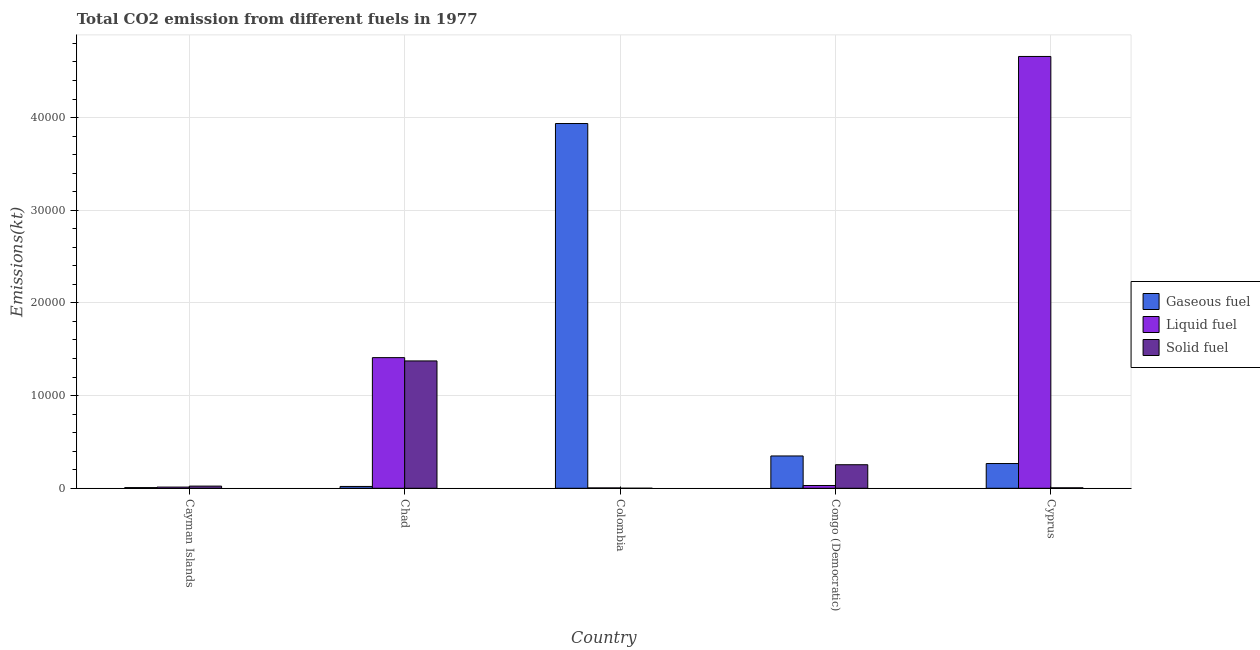How many groups of bars are there?
Provide a succinct answer. 5. Are the number of bars on each tick of the X-axis equal?
Keep it short and to the point. Yes. How many bars are there on the 2nd tick from the right?
Offer a terse response. 3. What is the label of the 4th group of bars from the left?
Your answer should be very brief. Congo (Democratic). In how many cases, is the number of bars for a given country not equal to the number of legend labels?
Give a very brief answer. 0. What is the amount of co2 emissions from solid fuel in Chad?
Provide a short and direct response. 1.37e+04. Across all countries, what is the maximum amount of co2 emissions from gaseous fuel?
Ensure brevity in your answer.  3.94e+04. Across all countries, what is the minimum amount of co2 emissions from solid fuel?
Your response must be concise. 3.67. In which country was the amount of co2 emissions from liquid fuel maximum?
Give a very brief answer. Cyprus. What is the total amount of co2 emissions from liquid fuel in the graph?
Offer a terse response. 6.12e+04. What is the difference between the amount of co2 emissions from liquid fuel in Chad and that in Colombia?
Make the answer very short. 1.41e+04. What is the difference between the amount of co2 emissions from solid fuel in Cyprus and the amount of co2 emissions from gaseous fuel in Colombia?
Provide a short and direct response. -3.93e+04. What is the average amount of co2 emissions from solid fuel per country?
Give a very brief answer. 3314.23. What is the difference between the amount of co2 emissions from solid fuel and amount of co2 emissions from gaseous fuel in Cayman Islands?
Provide a short and direct response. 161.35. In how many countries, is the amount of co2 emissions from gaseous fuel greater than 18000 kt?
Provide a succinct answer. 1. What is the ratio of the amount of co2 emissions from gaseous fuel in Chad to that in Congo (Democratic)?
Keep it short and to the point. 0.06. Is the amount of co2 emissions from solid fuel in Chad less than that in Congo (Democratic)?
Provide a short and direct response. No. What is the difference between the highest and the second highest amount of co2 emissions from solid fuel?
Provide a short and direct response. 1.12e+04. What is the difference between the highest and the lowest amount of co2 emissions from gaseous fuel?
Give a very brief answer. 3.93e+04. In how many countries, is the amount of co2 emissions from gaseous fuel greater than the average amount of co2 emissions from gaseous fuel taken over all countries?
Your answer should be compact. 1. Is the sum of the amount of co2 emissions from liquid fuel in Cayman Islands and Cyprus greater than the maximum amount of co2 emissions from solid fuel across all countries?
Offer a terse response. Yes. What does the 2nd bar from the left in Cayman Islands represents?
Give a very brief answer. Liquid fuel. What does the 2nd bar from the right in Colombia represents?
Make the answer very short. Liquid fuel. Is it the case that in every country, the sum of the amount of co2 emissions from gaseous fuel and amount of co2 emissions from liquid fuel is greater than the amount of co2 emissions from solid fuel?
Offer a terse response. No. How many bars are there?
Keep it short and to the point. 15. Are all the bars in the graph horizontal?
Keep it short and to the point. No. What is the difference between two consecutive major ticks on the Y-axis?
Give a very brief answer. 10000. Are the values on the major ticks of Y-axis written in scientific E-notation?
Provide a succinct answer. No. Does the graph contain any zero values?
Your answer should be very brief. No. Does the graph contain grids?
Provide a succinct answer. Yes. How many legend labels are there?
Provide a short and direct response. 3. What is the title of the graph?
Your answer should be compact. Total CO2 emission from different fuels in 1977. What is the label or title of the X-axis?
Give a very brief answer. Country. What is the label or title of the Y-axis?
Provide a short and direct response. Emissions(kt). What is the Emissions(kt) of Gaseous fuel in Cayman Islands?
Give a very brief answer. 73.34. What is the Emissions(kt) of Liquid fuel in Cayman Islands?
Give a very brief answer. 128.34. What is the Emissions(kt) of Solid fuel in Cayman Islands?
Make the answer very short. 234.69. What is the Emissions(kt) in Gaseous fuel in Chad?
Ensure brevity in your answer.  198.02. What is the Emissions(kt) of Liquid fuel in Chad?
Make the answer very short. 1.41e+04. What is the Emissions(kt) of Solid fuel in Chad?
Provide a succinct answer. 1.37e+04. What is the Emissions(kt) of Gaseous fuel in Colombia?
Make the answer very short. 3.94e+04. What is the Emissions(kt) in Liquid fuel in Colombia?
Your answer should be very brief. 40.34. What is the Emissions(kt) in Solid fuel in Colombia?
Ensure brevity in your answer.  3.67. What is the Emissions(kt) in Gaseous fuel in Congo (Democratic)?
Your answer should be very brief. 3487.32. What is the Emissions(kt) in Liquid fuel in Congo (Democratic)?
Your answer should be very brief. 300.69. What is the Emissions(kt) of Solid fuel in Congo (Democratic)?
Offer a terse response. 2541.23. What is the Emissions(kt) in Gaseous fuel in Cyprus?
Provide a succinct answer. 2669.58. What is the Emissions(kt) in Liquid fuel in Cyprus?
Give a very brief answer. 4.66e+04. What is the Emissions(kt) of Solid fuel in Cyprus?
Offer a very short reply. 51.34. Across all countries, what is the maximum Emissions(kt) in Gaseous fuel?
Your response must be concise. 3.94e+04. Across all countries, what is the maximum Emissions(kt) of Liquid fuel?
Your response must be concise. 4.66e+04. Across all countries, what is the maximum Emissions(kt) in Solid fuel?
Offer a very short reply. 1.37e+04. Across all countries, what is the minimum Emissions(kt) of Gaseous fuel?
Ensure brevity in your answer.  73.34. Across all countries, what is the minimum Emissions(kt) in Liquid fuel?
Your answer should be compact. 40.34. Across all countries, what is the minimum Emissions(kt) in Solid fuel?
Keep it short and to the point. 3.67. What is the total Emissions(kt) in Gaseous fuel in the graph?
Keep it short and to the point. 4.58e+04. What is the total Emissions(kt) of Liquid fuel in the graph?
Your response must be concise. 6.12e+04. What is the total Emissions(kt) of Solid fuel in the graph?
Offer a terse response. 1.66e+04. What is the difference between the Emissions(kt) of Gaseous fuel in Cayman Islands and that in Chad?
Your response must be concise. -124.68. What is the difference between the Emissions(kt) of Liquid fuel in Cayman Islands and that in Chad?
Your answer should be compact. -1.40e+04. What is the difference between the Emissions(kt) in Solid fuel in Cayman Islands and that in Chad?
Keep it short and to the point. -1.35e+04. What is the difference between the Emissions(kt) in Gaseous fuel in Cayman Islands and that in Colombia?
Provide a succinct answer. -3.93e+04. What is the difference between the Emissions(kt) in Liquid fuel in Cayman Islands and that in Colombia?
Your answer should be very brief. 88.01. What is the difference between the Emissions(kt) of Solid fuel in Cayman Islands and that in Colombia?
Your response must be concise. 231.02. What is the difference between the Emissions(kt) in Gaseous fuel in Cayman Islands and that in Congo (Democratic)?
Offer a terse response. -3413.98. What is the difference between the Emissions(kt) of Liquid fuel in Cayman Islands and that in Congo (Democratic)?
Make the answer very short. -172.35. What is the difference between the Emissions(kt) of Solid fuel in Cayman Islands and that in Congo (Democratic)?
Make the answer very short. -2306.54. What is the difference between the Emissions(kt) in Gaseous fuel in Cayman Islands and that in Cyprus?
Your response must be concise. -2596.24. What is the difference between the Emissions(kt) in Liquid fuel in Cayman Islands and that in Cyprus?
Your answer should be very brief. -4.65e+04. What is the difference between the Emissions(kt) of Solid fuel in Cayman Islands and that in Cyprus?
Provide a short and direct response. 183.35. What is the difference between the Emissions(kt) in Gaseous fuel in Chad and that in Colombia?
Offer a very short reply. -3.92e+04. What is the difference between the Emissions(kt) of Liquid fuel in Chad and that in Colombia?
Your answer should be compact. 1.41e+04. What is the difference between the Emissions(kt) of Solid fuel in Chad and that in Colombia?
Offer a very short reply. 1.37e+04. What is the difference between the Emissions(kt) in Gaseous fuel in Chad and that in Congo (Democratic)?
Offer a terse response. -3289.3. What is the difference between the Emissions(kt) of Liquid fuel in Chad and that in Congo (Democratic)?
Your answer should be very brief. 1.38e+04. What is the difference between the Emissions(kt) in Solid fuel in Chad and that in Congo (Democratic)?
Offer a very short reply. 1.12e+04. What is the difference between the Emissions(kt) in Gaseous fuel in Chad and that in Cyprus?
Make the answer very short. -2471.56. What is the difference between the Emissions(kt) of Liquid fuel in Chad and that in Cyprus?
Ensure brevity in your answer.  -3.25e+04. What is the difference between the Emissions(kt) in Solid fuel in Chad and that in Cyprus?
Make the answer very short. 1.37e+04. What is the difference between the Emissions(kt) in Gaseous fuel in Colombia and that in Congo (Democratic)?
Your response must be concise. 3.59e+04. What is the difference between the Emissions(kt) in Liquid fuel in Colombia and that in Congo (Democratic)?
Your response must be concise. -260.36. What is the difference between the Emissions(kt) of Solid fuel in Colombia and that in Congo (Democratic)?
Your answer should be compact. -2537.56. What is the difference between the Emissions(kt) of Gaseous fuel in Colombia and that in Cyprus?
Ensure brevity in your answer.  3.67e+04. What is the difference between the Emissions(kt) of Liquid fuel in Colombia and that in Cyprus?
Your answer should be compact. -4.65e+04. What is the difference between the Emissions(kt) of Solid fuel in Colombia and that in Cyprus?
Offer a terse response. -47.67. What is the difference between the Emissions(kt) in Gaseous fuel in Congo (Democratic) and that in Cyprus?
Provide a succinct answer. 817.74. What is the difference between the Emissions(kt) in Liquid fuel in Congo (Democratic) and that in Cyprus?
Make the answer very short. -4.63e+04. What is the difference between the Emissions(kt) of Solid fuel in Congo (Democratic) and that in Cyprus?
Your answer should be very brief. 2489.89. What is the difference between the Emissions(kt) in Gaseous fuel in Cayman Islands and the Emissions(kt) in Liquid fuel in Chad?
Offer a very short reply. -1.40e+04. What is the difference between the Emissions(kt) in Gaseous fuel in Cayman Islands and the Emissions(kt) in Solid fuel in Chad?
Provide a short and direct response. -1.37e+04. What is the difference between the Emissions(kt) in Liquid fuel in Cayman Islands and the Emissions(kt) in Solid fuel in Chad?
Provide a short and direct response. -1.36e+04. What is the difference between the Emissions(kt) in Gaseous fuel in Cayman Islands and the Emissions(kt) in Liquid fuel in Colombia?
Your answer should be very brief. 33. What is the difference between the Emissions(kt) of Gaseous fuel in Cayman Islands and the Emissions(kt) of Solid fuel in Colombia?
Keep it short and to the point. 69.67. What is the difference between the Emissions(kt) in Liquid fuel in Cayman Islands and the Emissions(kt) in Solid fuel in Colombia?
Offer a very short reply. 124.68. What is the difference between the Emissions(kt) of Gaseous fuel in Cayman Islands and the Emissions(kt) of Liquid fuel in Congo (Democratic)?
Ensure brevity in your answer.  -227.35. What is the difference between the Emissions(kt) in Gaseous fuel in Cayman Islands and the Emissions(kt) in Solid fuel in Congo (Democratic)?
Give a very brief answer. -2467.89. What is the difference between the Emissions(kt) of Liquid fuel in Cayman Islands and the Emissions(kt) of Solid fuel in Congo (Democratic)?
Make the answer very short. -2412.89. What is the difference between the Emissions(kt) of Gaseous fuel in Cayman Islands and the Emissions(kt) of Liquid fuel in Cyprus?
Provide a succinct answer. -4.65e+04. What is the difference between the Emissions(kt) of Gaseous fuel in Cayman Islands and the Emissions(kt) of Solid fuel in Cyprus?
Offer a terse response. 22. What is the difference between the Emissions(kt) in Liquid fuel in Cayman Islands and the Emissions(kt) in Solid fuel in Cyprus?
Give a very brief answer. 77.01. What is the difference between the Emissions(kt) of Gaseous fuel in Chad and the Emissions(kt) of Liquid fuel in Colombia?
Keep it short and to the point. 157.68. What is the difference between the Emissions(kt) of Gaseous fuel in Chad and the Emissions(kt) of Solid fuel in Colombia?
Provide a short and direct response. 194.35. What is the difference between the Emissions(kt) of Liquid fuel in Chad and the Emissions(kt) of Solid fuel in Colombia?
Make the answer very short. 1.41e+04. What is the difference between the Emissions(kt) of Gaseous fuel in Chad and the Emissions(kt) of Liquid fuel in Congo (Democratic)?
Offer a terse response. -102.68. What is the difference between the Emissions(kt) of Gaseous fuel in Chad and the Emissions(kt) of Solid fuel in Congo (Democratic)?
Your answer should be compact. -2343.21. What is the difference between the Emissions(kt) of Liquid fuel in Chad and the Emissions(kt) of Solid fuel in Congo (Democratic)?
Provide a succinct answer. 1.16e+04. What is the difference between the Emissions(kt) of Gaseous fuel in Chad and the Emissions(kt) of Liquid fuel in Cyprus?
Give a very brief answer. -4.64e+04. What is the difference between the Emissions(kt) of Gaseous fuel in Chad and the Emissions(kt) of Solid fuel in Cyprus?
Your response must be concise. 146.68. What is the difference between the Emissions(kt) in Liquid fuel in Chad and the Emissions(kt) in Solid fuel in Cyprus?
Your answer should be compact. 1.40e+04. What is the difference between the Emissions(kt) in Gaseous fuel in Colombia and the Emissions(kt) in Liquid fuel in Congo (Democratic)?
Keep it short and to the point. 3.91e+04. What is the difference between the Emissions(kt) of Gaseous fuel in Colombia and the Emissions(kt) of Solid fuel in Congo (Democratic)?
Ensure brevity in your answer.  3.68e+04. What is the difference between the Emissions(kt) of Liquid fuel in Colombia and the Emissions(kt) of Solid fuel in Congo (Democratic)?
Provide a short and direct response. -2500.89. What is the difference between the Emissions(kt) in Gaseous fuel in Colombia and the Emissions(kt) in Liquid fuel in Cyprus?
Provide a succinct answer. -7234.99. What is the difference between the Emissions(kt) of Gaseous fuel in Colombia and the Emissions(kt) of Solid fuel in Cyprus?
Your response must be concise. 3.93e+04. What is the difference between the Emissions(kt) of Liquid fuel in Colombia and the Emissions(kt) of Solid fuel in Cyprus?
Offer a very short reply. -11. What is the difference between the Emissions(kt) in Gaseous fuel in Congo (Democratic) and the Emissions(kt) in Liquid fuel in Cyprus?
Make the answer very short. -4.31e+04. What is the difference between the Emissions(kt) of Gaseous fuel in Congo (Democratic) and the Emissions(kt) of Solid fuel in Cyprus?
Offer a terse response. 3435.98. What is the difference between the Emissions(kt) of Liquid fuel in Congo (Democratic) and the Emissions(kt) of Solid fuel in Cyprus?
Keep it short and to the point. 249.36. What is the average Emissions(kt) in Gaseous fuel per country?
Give a very brief answer. 9156.5. What is the average Emissions(kt) in Liquid fuel per country?
Provide a short and direct response. 1.22e+04. What is the average Emissions(kt) of Solid fuel per country?
Your response must be concise. 3314.23. What is the difference between the Emissions(kt) of Gaseous fuel and Emissions(kt) of Liquid fuel in Cayman Islands?
Keep it short and to the point. -55.01. What is the difference between the Emissions(kt) of Gaseous fuel and Emissions(kt) of Solid fuel in Cayman Islands?
Provide a short and direct response. -161.35. What is the difference between the Emissions(kt) in Liquid fuel and Emissions(kt) in Solid fuel in Cayman Islands?
Your answer should be compact. -106.34. What is the difference between the Emissions(kt) of Gaseous fuel and Emissions(kt) of Liquid fuel in Chad?
Offer a terse response. -1.39e+04. What is the difference between the Emissions(kt) of Gaseous fuel and Emissions(kt) of Solid fuel in Chad?
Provide a short and direct response. -1.35e+04. What is the difference between the Emissions(kt) of Liquid fuel and Emissions(kt) of Solid fuel in Chad?
Your answer should be compact. 355.7. What is the difference between the Emissions(kt) of Gaseous fuel and Emissions(kt) of Liquid fuel in Colombia?
Provide a short and direct response. 3.93e+04. What is the difference between the Emissions(kt) in Gaseous fuel and Emissions(kt) in Solid fuel in Colombia?
Your response must be concise. 3.94e+04. What is the difference between the Emissions(kt) of Liquid fuel and Emissions(kt) of Solid fuel in Colombia?
Offer a terse response. 36.67. What is the difference between the Emissions(kt) in Gaseous fuel and Emissions(kt) in Liquid fuel in Congo (Democratic)?
Offer a terse response. 3186.62. What is the difference between the Emissions(kt) in Gaseous fuel and Emissions(kt) in Solid fuel in Congo (Democratic)?
Provide a short and direct response. 946.09. What is the difference between the Emissions(kt) in Liquid fuel and Emissions(kt) in Solid fuel in Congo (Democratic)?
Offer a terse response. -2240.54. What is the difference between the Emissions(kt) of Gaseous fuel and Emissions(kt) of Liquid fuel in Cyprus?
Offer a terse response. -4.39e+04. What is the difference between the Emissions(kt) of Gaseous fuel and Emissions(kt) of Solid fuel in Cyprus?
Ensure brevity in your answer.  2618.24. What is the difference between the Emissions(kt) in Liquid fuel and Emissions(kt) in Solid fuel in Cyprus?
Provide a short and direct response. 4.65e+04. What is the ratio of the Emissions(kt) in Gaseous fuel in Cayman Islands to that in Chad?
Make the answer very short. 0.37. What is the ratio of the Emissions(kt) of Liquid fuel in Cayman Islands to that in Chad?
Your response must be concise. 0.01. What is the ratio of the Emissions(kt) in Solid fuel in Cayman Islands to that in Chad?
Provide a short and direct response. 0.02. What is the ratio of the Emissions(kt) in Gaseous fuel in Cayman Islands to that in Colombia?
Make the answer very short. 0. What is the ratio of the Emissions(kt) of Liquid fuel in Cayman Islands to that in Colombia?
Offer a terse response. 3.18. What is the ratio of the Emissions(kt) of Gaseous fuel in Cayman Islands to that in Congo (Democratic)?
Offer a very short reply. 0.02. What is the ratio of the Emissions(kt) of Liquid fuel in Cayman Islands to that in Congo (Democratic)?
Provide a short and direct response. 0.43. What is the ratio of the Emissions(kt) in Solid fuel in Cayman Islands to that in Congo (Democratic)?
Provide a succinct answer. 0.09. What is the ratio of the Emissions(kt) of Gaseous fuel in Cayman Islands to that in Cyprus?
Your answer should be compact. 0.03. What is the ratio of the Emissions(kt) in Liquid fuel in Cayman Islands to that in Cyprus?
Your answer should be compact. 0. What is the ratio of the Emissions(kt) of Solid fuel in Cayman Islands to that in Cyprus?
Give a very brief answer. 4.57. What is the ratio of the Emissions(kt) in Gaseous fuel in Chad to that in Colombia?
Give a very brief answer. 0.01. What is the ratio of the Emissions(kt) in Liquid fuel in Chad to that in Colombia?
Make the answer very short. 349.45. What is the ratio of the Emissions(kt) of Solid fuel in Chad to that in Colombia?
Your answer should be very brief. 3747. What is the ratio of the Emissions(kt) in Gaseous fuel in Chad to that in Congo (Democratic)?
Your answer should be compact. 0.06. What is the ratio of the Emissions(kt) in Liquid fuel in Chad to that in Congo (Democratic)?
Offer a terse response. 46.88. What is the ratio of the Emissions(kt) in Solid fuel in Chad to that in Congo (Democratic)?
Your answer should be very brief. 5.41. What is the ratio of the Emissions(kt) in Gaseous fuel in Chad to that in Cyprus?
Keep it short and to the point. 0.07. What is the ratio of the Emissions(kt) in Liquid fuel in Chad to that in Cyprus?
Your response must be concise. 0.3. What is the ratio of the Emissions(kt) of Solid fuel in Chad to that in Cyprus?
Your answer should be very brief. 267.64. What is the ratio of the Emissions(kt) of Gaseous fuel in Colombia to that in Congo (Democratic)?
Ensure brevity in your answer.  11.29. What is the ratio of the Emissions(kt) in Liquid fuel in Colombia to that in Congo (Democratic)?
Offer a terse response. 0.13. What is the ratio of the Emissions(kt) of Solid fuel in Colombia to that in Congo (Democratic)?
Provide a succinct answer. 0. What is the ratio of the Emissions(kt) of Gaseous fuel in Colombia to that in Cyprus?
Your answer should be compact. 14.74. What is the ratio of the Emissions(kt) of Liquid fuel in Colombia to that in Cyprus?
Your answer should be very brief. 0. What is the ratio of the Emissions(kt) in Solid fuel in Colombia to that in Cyprus?
Provide a succinct answer. 0.07. What is the ratio of the Emissions(kt) in Gaseous fuel in Congo (Democratic) to that in Cyprus?
Ensure brevity in your answer.  1.31. What is the ratio of the Emissions(kt) of Liquid fuel in Congo (Democratic) to that in Cyprus?
Ensure brevity in your answer.  0.01. What is the ratio of the Emissions(kt) of Solid fuel in Congo (Democratic) to that in Cyprus?
Offer a very short reply. 49.5. What is the difference between the highest and the second highest Emissions(kt) in Gaseous fuel?
Give a very brief answer. 3.59e+04. What is the difference between the highest and the second highest Emissions(kt) of Liquid fuel?
Keep it short and to the point. 3.25e+04. What is the difference between the highest and the second highest Emissions(kt) in Solid fuel?
Provide a short and direct response. 1.12e+04. What is the difference between the highest and the lowest Emissions(kt) in Gaseous fuel?
Your answer should be very brief. 3.93e+04. What is the difference between the highest and the lowest Emissions(kt) in Liquid fuel?
Make the answer very short. 4.65e+04. What is the difference between the highest and the lowest Emissions(kt) of Solid fuel?
Your response must be concise. 1.37e+04. 